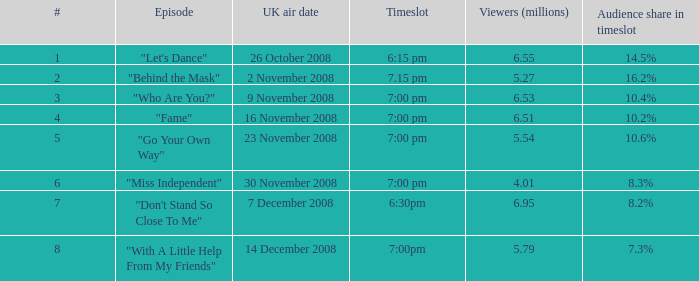9 7.0. 